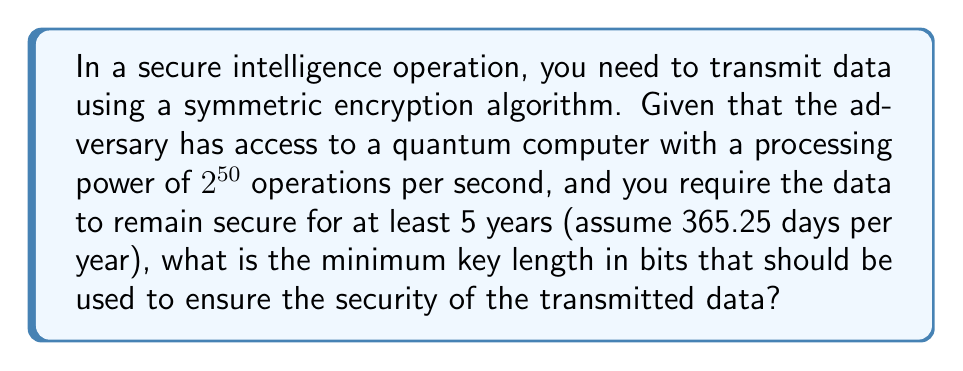Show me your answer to this math problem. To determine the optimal key length, we need to consider the following steps:

1. Calculate the total number of operations the adversary can perform in 5 years:
   $$ \text{Total operations} = 2^{50} \times 60 \times 60 \times 24 \times 365.25 \times 5 $$
   $$ = 2^{50} \times 157,788,000 $$
   $$ \approx 2^{77.2} $$

2. In cryptography, we typically aim for a security margin that is at least $2^{80}$ operations to ensure adequate protection. Given the calculated value, we should aim for a key space larger than $2^{80}$.

3. The key space size is determined by the key length. For a key of length $n$ bits, the key space is $2^n$.

4. To find the minimum key length, we need to solve the equation:
   $$ 2^n > 2^{80} $$

5. Taking the logarithm of both sides:
   $$ n > 80 $$

6. Since key lengths are typically multiples of 8 in practical cryptographic systems, we round up to the nearest multiple of 8.

Therefore, the minimum key length should be 88 bits. However, in practice, we often use standard key sizes that provide an extra security margin. The next standard key size above 88 bits is 128 bits.
Answer: 128 bits 